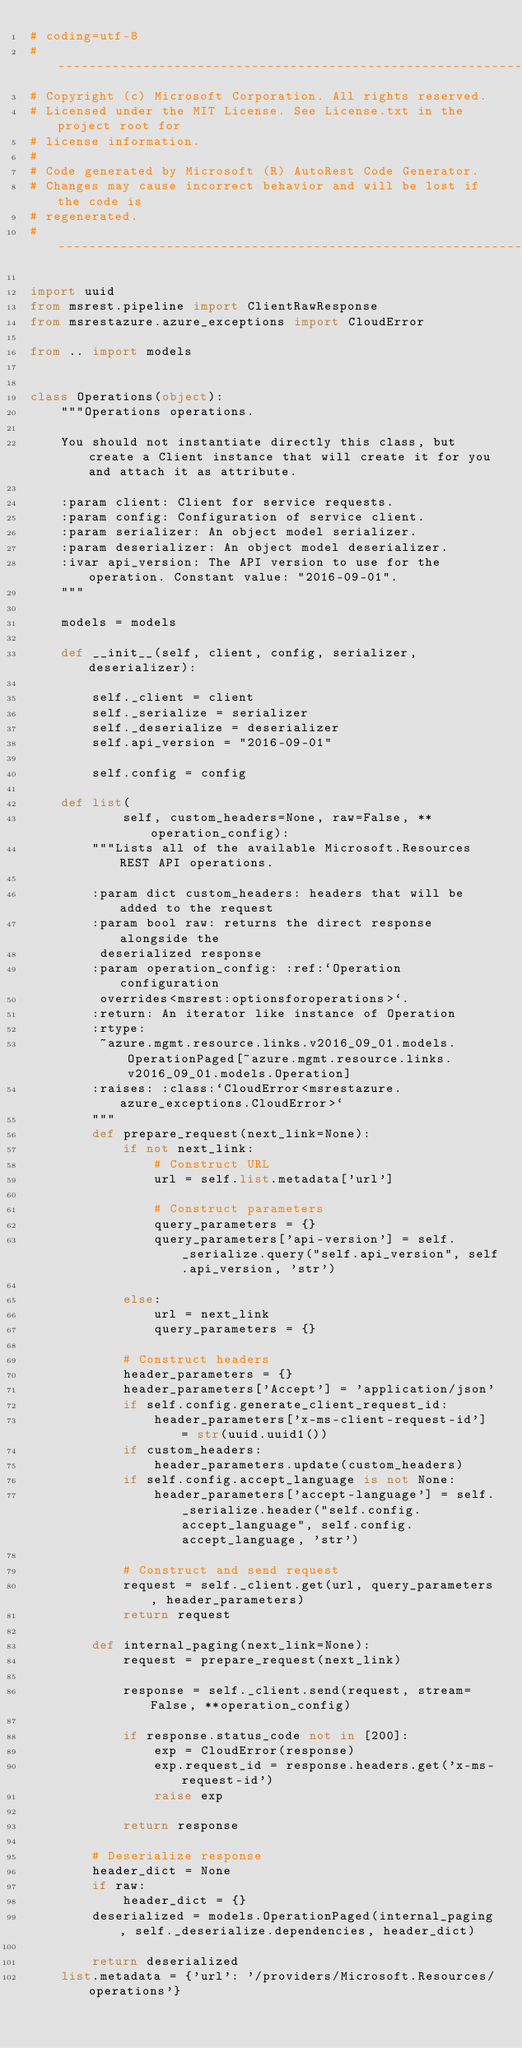<code> <loc_0><loc_0><loc_500><loc_500><_Python_># coding=utf-8
# --------------------------------------------------------------------------
# Copyright (c) Microsoft Corporation. All rights reserved.
# Licensed under the MIT License. See License.txt in the project root for
# license information.
#
# Code generated by Microsoft (R) AutoRest Code Generator.
# Changes may cause incorrect behavior and will be lost if the code is
# regenerated.
# --------------------------------------------------------------------------

import uuid
from msrest.pipeline import ClientRawResponse
from msrestazure.azure_exceptions import CloudError

from .. import models


class Operations(object):
    """Operations operations.

    You should not instantiate directly this class, but create a Client instance that will create it for you and attach it as attribute.

    :param client: Client for service requests.
    :param config: Configuration of service client.
    :param serializer: An object model serializer.
    :param deserializer: An object model deserializer.
    :ivar api_version: The API version to use for the operation. Constant value: "2016-09-01".
    """

    models = models

    def __init__(self, client, config, serializer, deserializer):

        self._client = client
        self._serialize = serializer
        self._deserialize = deserializer
        self.api_version = "2016-09-01"

        self.config = config

    def list(
            self, custom_headers=None, raw=False, **operation_config):
        """Lists all of the available Microsoft.Resources REST API operations.

        :param dict custom_headers: headers that will be added to the request
        :param bool raw: returns the direct response alongside the
         deserialized response
        :param operation_config: :ref:`Operation configuration
         overrides<msrest:optionsforoperations>`.
        :return: An iterator like instance of Operation
        :rtype:
         ~azure.mgmt.resource.links.v2016_09_01.models.OperationPaged[~azure.mgmt.resource.links.v2016_09_01.models.Operation]
        :raises: :class:`CloudError<msrestazure.azure_exceptions.CloudError>`
        """
        def prepare_request(next_link=None):
            if not next_link:
                # Construct URL
                url = self.list.metadata['url']

                # Construct parameters
                query_parameters = {}
                query_parameters['api-version'] = self._serialize.query("self.api_version", self.api_version, 'str')

            else:
                url = next_link
                query_parameters = {}

            # Construct headers
            header_parameters = {}
            header_parameters['Accept'] = 'application/json'
            if self.config.generate_client_request_id:
                header_parameters['x-ms-client-request-id'] = str(uuid.uuid1())
            if custom_headers:
                header_parameters.update(custom_headers)
            if self.config.accept_language is not None:
                header_parameters['accept-language'] = self._serialize.header("self.config.accept_language", self.config.accept_language, 'str')

            # Construct and send request
            request = self._client.get(url, query_parameters, header_parameters)
            return request

        def internal_paging(next_link=None):
            request = prepare_request(next_link)

            response = self._client.send(request, stream=False, **operation_config)

            if response.status_code not in [200]:
                exp = CloudError(response)
                exp.request_id = response.headers.get('x-ms-request-id')
                raise exp

            return response

        # Deserialize response
        header_dict = None
        if raw:
            header_dict = {}
        deserialized = models.OperationPaged(internal_paging, self._deserialize.dependencies, header_dict)

        return deserialized
    list.metadata = {'url': '/providers/Microsoft.Resources/operations'}
</code> 